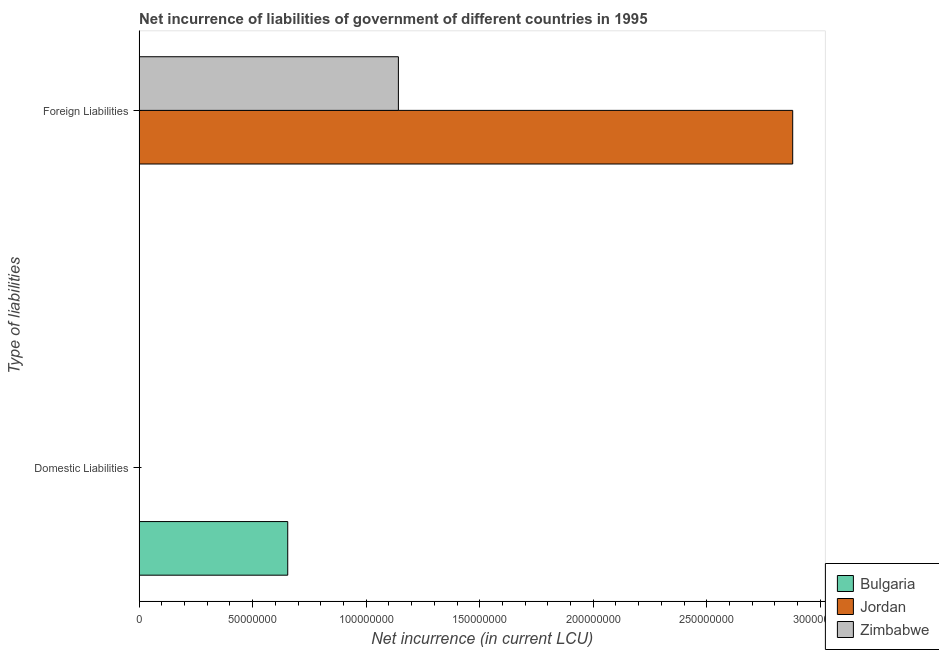Are the number of bars on each tick of the Y-axis equal?
Your answer should be very brief. No. How many bars are there on the 1st tick from the top?
Give a very brief answer. 2. What is the label of the 1st group of bars from the top?
Ensure brevity in your answer.  Foreign Liabilities. Across all countries, what is the maximum net incurrence of foreign liabilities?
Provide a succinct answer. 2.88e+08. What is the total net incurrence of domestic liabilities in the graph?
Offer a terse response. 6.55e+07. What is the difference between the net incurrence of foreign liabilities in Jordan and that in Zimbabwe?
Offer a very short reply. 1.74e+08. What is the difference between the net incurrence of domestic liabilities in Jordan and the net incurrence of foreign liabilities in Bulgaria?
Provide a succinct answer. 0. What is the average net incurrence of domestic liabilities per country?
Your answer should be compact. 2.18e+07. In how many countries, is the net incurrence of domestic liabilities greater than 260000000 LCU?
Your answer should be compact. 0. In how many countries, is the net incurrence of foreign liabilities greater than the average net incurrence of foreign liabilities taken over all countries?
Your response must be concise. 1. How many bars are there?
Make the answer very short. 3. Are all the bars in the graph horizontal?
Make the answer very short. Yes. Are the values on the major ticks of X-axis written in scientific E-notation?
Provide a short and direct response. No. Where does the legend appear in the graph?
Your answer should be very brief. Bottom right. How many legend labels are there?
Offer a very short reply. 3. How are the legend labels stacked?
Keep it short and to the point. Vertical. What is the title of the graph?
Offer a very short reply. Net incurrence of liabilities of government of different countries in 1995. What is the label or title of the X-axis?
Your response must be concise. Net incurrence (in current LCU). What is the label or title of the Y-axis?
Provide a succinct answer. Type of liabilities. What is the Net incurrence (in current LCU) of Bulgaria in Domestic Liabilities?
Give a very brief answer. 6.55e+07. What is the Net incurrence (in current LCU) in Jordan in Domestic Liabilities?
Provide a short and direct response. 0. What is the Net incurrence (in current LCU) of Bulgaria in Foreign Liabilities?
Offer a terse response. 0. What is the Net incurrence (in current LCU) of Jordan in Foreign Liabilities?
Keep it short and to the point. 2.88e+08. What is the Net incurrence (in current LCU) in Zimbabwe in Foreign Liabilities?
Ensure brevity in your answer.  1.14e+08. Across all Type of liabilities, what is the maximum Net incurrence (in current LCU) in Bulgaria?
Give a very brief answer. 6.55e+07. Across all Type of liabilities, what is the maximum Net incurrence (in current LCU) in Jordan?
Provide a succinct answer. 2.88e+08. Across all Type of liabilities, what is the maximum Net incurrence (in current LCU) of Zimbabwe?
Provide a short and direct response. 1.14e+08. Across all Type of liabilities, what is the minimum Net incurrence (in current LCU) in Bulgaria?
Ensure brevity in your answer.  0. Across all Type of liabilities, what is the minimum Net incurrence (in current LCU) in Jordan?
Your response must be concise. 0. What is the total Net incurrence (in current LCU) of Bulgaria in the graph?
Keep it short and to the point. 6.55e+07. What is the total Net incurrence (in current LCU) in Jordan in the graph?
Your answer should be compact. 2.88e+08. What is the total Net incurrence (in current LCU) in Zimbabwe in the graph?
Your answer should be very brief. 1.14e+08. What is the difference between the Net incurrence (in current LCU) of Bulgaria in Domestic Liabilities and the Net incurrence (in current LCU) of Jordan in Foreign Liabilities?
Provide a short and direct response. -2.22e+08. What is the difference between the Net incurrence (in current LCU) in Bulgaria in Domestic Liabilities and the Net incurrence (in current LCU) in Zimbabwe in Foreign Liabilities?
Offer a very short reply. -4.87e+07. What is the average Net incurrence (in current LCU) of Bulgaria per Type of liabilities?
Ensure brevity in your answer.  3.27e+07. What is the average Net incurrence (in current LCU) of Jordan per Type of liabilities?
Keep it short and to the point. 1.44e+08. What is the average Net incurrence (in current LCU) in Zimbabwe per Type of liabilities?
Keep it short and to the point. 5.71e+07. What is the difference between the Net incurrence (in current LCU) of Jordan and Net incurrence (in current LCU) of Zimbabwe in Foreign Liabilities?
Provide a short and direct response. 1.74e+08. What is the difference between the highest and the lowest Net incurrence (in current LCU) in Bulgaria?
Provide a short and direct response. 6.55e+07. What is the difference between the highest and the lowest Net incurrence (in current LCU) in Jordan?
Offer a terse response. 2.88e+08. What is the difference between the highest and the lowest Net incurrence (in current LCU) of Zimbabwe?
Offer a very short reply. 1.14e+08. 